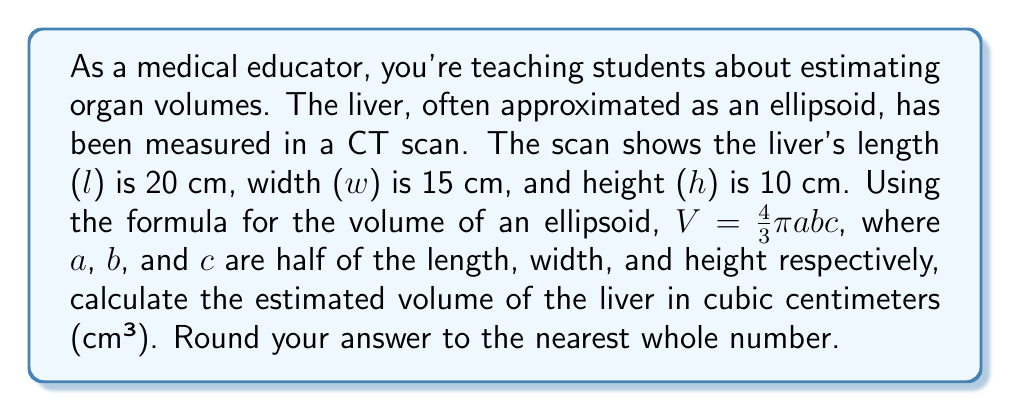Teach me how to tackle this problem. Let's approach this step-by-step:

1) We're given the dimensions of the liver:
   Length (l) = 20 cm
   Width (w) = 15 cm
   Height (h) = 10 cm

2) The formula for the volume of an ellipsoid is:
   $$V = \frac{4}{3}\pi abc$$
   where a, b, and c are half of the length, width, and height respectively.

3) Let's calculate a, b, and c:
   $a = \frac{l}{2} = \frac{20}{2} = 10$ cm
   $b = \frac{w}{2} = \frac{15}{2} = 7.5$ cm
   $c = \frac{h}{2} = \frac{10}{2} = 5$ cm

4) Now, let's substitute these values into the formula:
   $$V = \frac{4}{3}\pi(10)(7.5)(5)$$

5) Simplify:
   $$V = \frac{4}{3}\pi(375)$$

6) Calculate:
   $$V = 500\pi \approx 1570.80$ cm³

7) Rounding to the nearest whole number:
   $V \approx 1571$ cm³
Answer: 1571 cm³ 